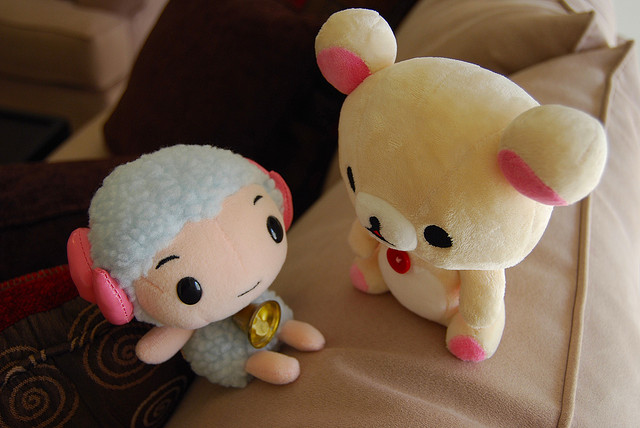<image>What game is depicted by these characters? I don't know which game is currently depicted. It could be anything from 'pokemon', 'jem world', 'warcraft', or others. What game is depicted by these characters? I am not sure what game is depicted by these characters. It can be seen 'pokemon' or 'warcraft'. 